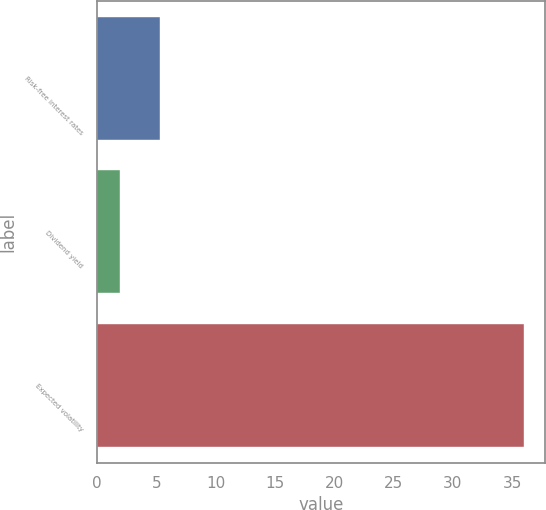<chart> <loc_0><loc_0><loc_500><loc_500><bar_chart><fcel>Risk-free interest rates<fcel>Dividend yield<fcel>Expected volatility<nl><fcel>5.34<fcel>1.93<fcel>36<nl></chart> 